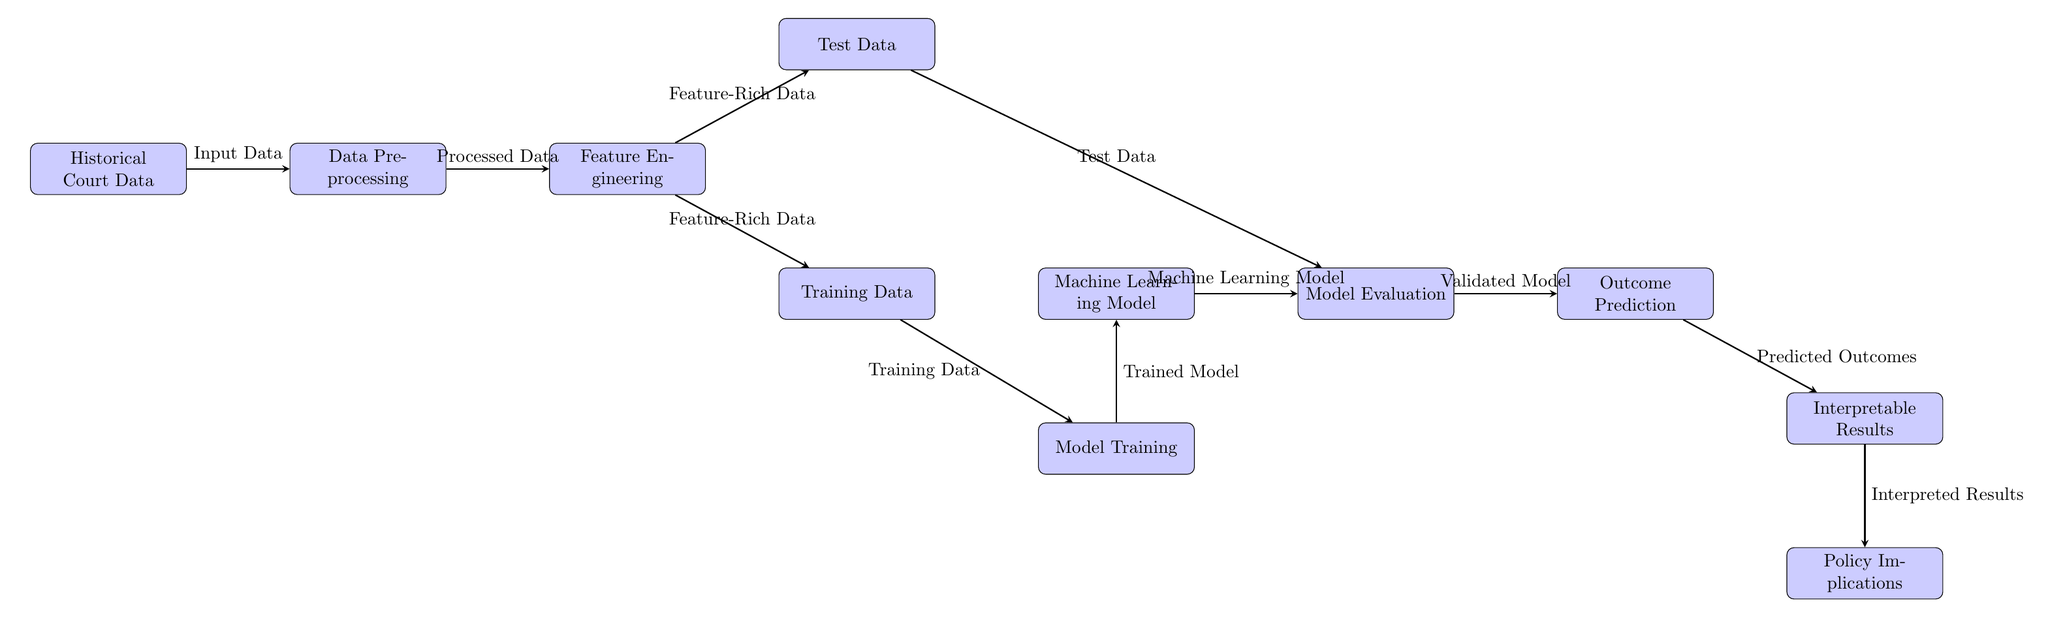What is the first step in the process? The first step in the process as indicated in the diagram is represented by the node labeled "Historical Court Data". This shows that the starting point for the prediction model is historical court data, which is used as input for the next stages.
Answer: Historical Court Data How many nodes are there in the diagram? To determine the total number of nodes, I count each labeled box in the diagram, which amounts to eleven distinct process nodes.
Answer: 11 What is used to generate the Model Evaluation? The node labeled "Test Data" is used to feed into the "Model Evaluation" node, as shown by the directed arrow connecting these two nodes, indicating it is the basis for evaluating the model's performance.
Answer: Test Data Which process follows Feature Engineering? According to the flow of the diagram, the "Training Data" and "Test Data" processes emerge from the "Feature Engineering" step, demonstrating that they are both subsequent outputs of this stage. Therefore, both are the direct follow-ups, but if we focus on a singular follow-up to "Feature Engineering," "Training Data" comes first.
Answer: Training Data What happens after Model Evaluation in this diagram? Once the "Model Evaluation" process is complete, the next step highlighted in the diagram is "Outcome Prediction," which signifies that once a model has been validated, it proceeds to predict outcomes based on that evaluation.
Answer: Outcome Prediction What type of data is created after Data Preprocessing? The output of the "Data Preprocessing" step is labeled as "Processed Data," indicating the clean and structured data that moves to the next step of "Feature Engineering."
Answer: Processed Data What is the final output of this machine learning process? The final output of the machine learning process, as depicted in the last step of the diagram, is "Policy Implications," which indicates the actionable insights derived from the interpreted results.
Answer: Policy Implications Which step involves creating a Model? The creation of the "Machine Learning Model" occurs after "Model Training," as indicated by the arrows, which signifies that the model is developed using the trained data processed in the previous steps.
Answer: Machine Learning Model What resource feeds into Model Training? The "Training Data" node is the input that feeds into the "Model Training" step in the diagram, where the machine learning model is trained on this dataset.
Answer: Training Data 